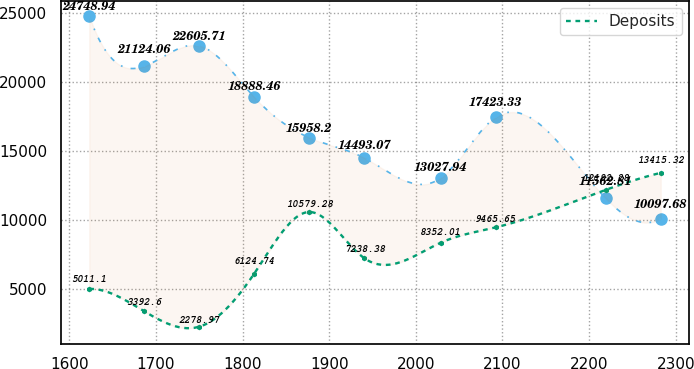Convert chart to OTSL. <chart><loc_0><loc_0><loc_500><loc_500><line_chart><ecel><fcel>Unnamed: 1<fcel>Deposits<nl><fcel>1622.96<fcel>24748.9<fcel>5011.1<nl><fcel>1686.45<fcel>21124.1<fcel>3392.6<nl><fcel>1749.94<fcel>22605.7<fcel>2278.97<nl><fcel>1813.43<fcel>18888.5<fcel>6124.74<nl><fcel>1876.92<fcel>15958.2<fcel>10579.3<nl><fcel>1940.41<fcel>14493.1<fcel>7238.38<nl><fcel>2028.49<fcel>13027.9<fcel>8352.01<nl><fcel>2091.98<fcel>17423.3<fcel>9465.65<nl><fcel>2219.22<fcel>11562.8<fcel>12182.3<nl><fcel>2282.71<fcel>10097.7<fcel>13415.3<nl></chart> 